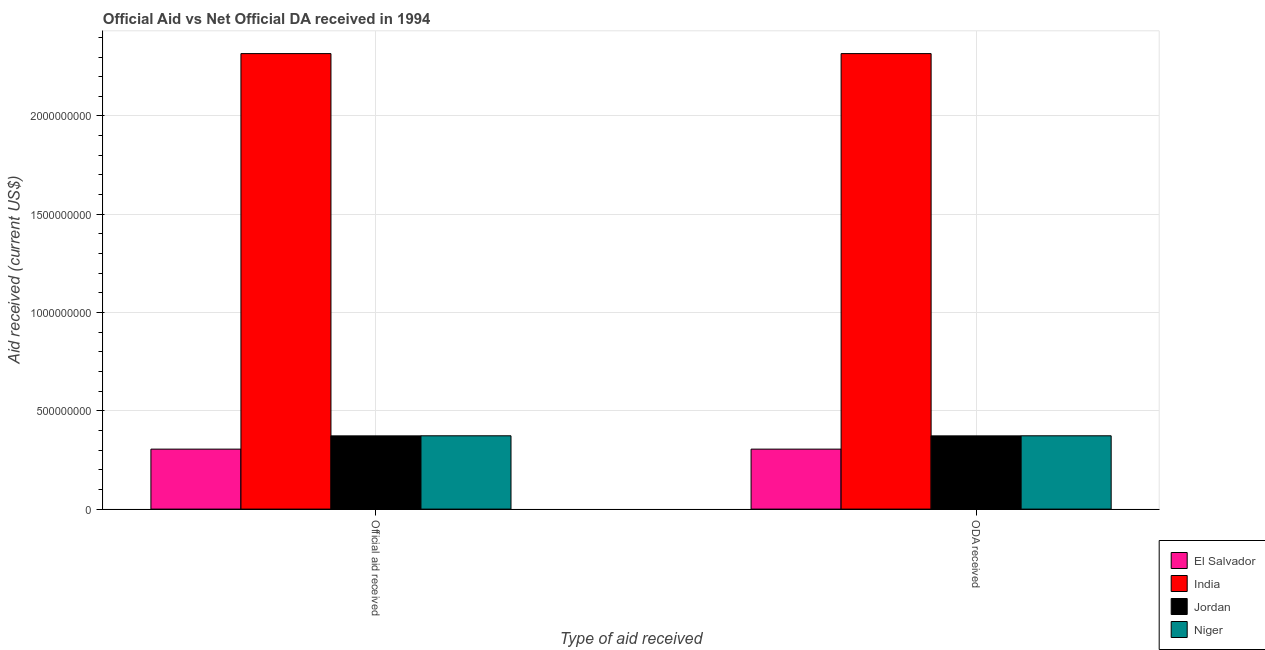How many groups of bars are there?
Your answer should be very brief. 2. Are the number of bars on each tick of the X-axis equal?
Your answer should be very brief. Yes. How many bars are there on the 1st tick from the left?
Give a very brief answer. 4. How many bars are there on the 2nd tick from the right?
Offer a terse response. 4. What is the label of the 2nd group of bars from the left?
Provide a succinct answer. ODA received. What is the oda received in India?
Keep it short and to the point. 2.32e+09. Across all countries, what is the maximum official aid received?
Keep it short and to the point. 2.32e+09. Across all countries, what is the minimum oda received?
Your answer should be compact. 3.05e+08. In which country was the oda received maximum?
Make the answer very short. India. In which country was the official aid received minimum?
Give a very brief answer. El Salvador. What is the total oda received in the graph?
Your answer should be very brief. 3.37e+09. What is the difference between the official aid received in India and that in El Salvador?
Offer a terse response. 2.01e+09. What is the difference between the official aid received in India and the oda received in Jordan?
Your response must be concise. 1.94e+09. What is the average oda received per country?
Your answer should be very brief. 8.42e+08. In how many countries, is the official aid received greater than 100000000 US$?
Your answer should be compact. 4. What is the ratio of the official aid received in India to that in Jordan?
Your answer should be very brief. 6.22. What does the 3rd bar from the left in Official aid received represents?
Your answer should be very brief. Jordan. What does the 1st bar from the right in Official aid received represents?
Make the answer very short. Niger. How many bars are there?
Provide a short and direct response. 8. Are the values on the major ticks of Y-axis written in scientific E-notation?
Your response must be concise. No. Does the graph contain any zero values?
Keep it short and to the point. No. How many legend labels are there?
Keep it short and to the point. 4. How are the legend labels stacked?
Provide a succinct answer. Vertical. What is the title of the graph?
Your response must be concise. Official Aid vs Net Official DA received in 1994 . Does "Barbados" appear as one of the legend labels in the graph?
Make the answer very short. No. What is the label or title of the X-axis?
Ensure brevity in your answer.  Type of aid received. What is the label or title of the Y-axis?
Offer a very short reply. Aid received (current US$). What is the Aid received (current US$) of El Salvador in Official aid received?
Your response must be concise. 3.05e+08. What is the Aid received (current US$) of India in Official aid received?
Offer a terse response. 2.32e+09. What is the Aid received (current US$) of Jordan in Official aid received?
Keep it short and to the point. 3.73e+08. What is the Aid received (current US$) in Niger in Official aid received?
Give a very brief answer. 3.73e+08. What is the Aid received (current US$) in El Salvador in ODA received?
Give a very brief answer. 3.05e+08. What is the Aid received (current US$) in India in ODA received?
Offer a very short reply. 2.32e+09. What is the Aid received (current US$) of Jordan in ODA received?
Keep it short and to the point. 3.73e+08. What is the Aid received (current US$) in Niger in ODA received?
Provide a short and direct response. 3.73e+08. Across all Type of aid received, what is the maximum Aid received (current US$) in El Salvador?
Make the answer very short. 3.05e+08. Across all Type of aid received, what is the maximum Aid received (current US$) in India?
Offer a terse response. 2.32e+09. Across all Type of aid received, what is the maximum Aid received (current US$) in Jordan?
Ensure brevity in your answer.  3.73e+08. Across all Type of aid received, what is the maximum Aid received (current US$) in Niger?
Offer a very short reply. 3.73e+08. Across all Type of aid received, what is the minimum Aid received (current US$) of El Salvador?
Offer a terse response. 3.05e+08. Across all Type of aid received, what is the minimum Aid received (current US$) in India?
Your answer should be compact. 2.32e+09. Across all Type of aid received, what is the minimum Aid received (current US$) in Jordan?
Offer a very short reply. 3.73e+08. Across all Type of aid received, what is the minimum Aid received (current US$) in Niger?
Give a very brief answer. 3.73e+08. What is the total Aid received (current US$) of El Salvador in the graph?
Provide a short and direct response. 6.10e+08. What is the total Aid received (current US$) in India in the graph?
Ensure brevity in your answer.  4.63e+09. What is the total Aid received (current US$) of Jordan in the graph?
Keep it short and to the point. 7.45e+08. What is the total Aid received (current US$) in Niger in the graph?
Offer a very short reply. 7.46e+08. What is the difference between the Aid received (current US$) in Niger in Official aid received and that in ODA received?
Offer a terse response. 0. What is the difference between the Aid received (current US$) in El Salvador in Official aid received and the Aid received (current US$) in India in ODA received?
Provide a short and direct response. -2.01e+09. What is the difference between the Aid received (current US$) in El Salvador in Official aid received and the Aid received (current US$) in Jordan in ODA received?
Make the answer very short. -6.74e+07. What is the difference between the Aid received (current US$) of El Salvador in Official aid received and the Aid received (current US$) of Niger in ODA received?
Offer a very short reply. -6.78e+07. What is the difference between the Aid received (current US$) of India in Official aid received and the Aid received (current US$) of Jordan in ODA received?
Offer a terse response. 1.94e+09. What is the difference between the Aid received (current US$) in India in Official aid received and the Aid received (current US$) in Niger in ODA received?
Your answer should be compact. 1.94e+09. What is the difference between the Aid received (current US$) in Jordan in Official aid received and the Aid received (current US$) in Niger in ODA received?
Provide a succinct answer. -4.00e+05. What is the average Aid received (current US$) in El Salvador per Type of aid received?
Ensure brevity in your answer.  3.05e+08. What is the average Aid received (current US$) in India per Type of aid received?
Provide a succinct answer. 2.32e+09. What is the average Aid received (current US$) of Jordan per Type of aid received?
Your response must be concise. 3.73e+08. What is the average Aid received (current US$) of Niger per Type of aid received?
Provide a short and direct response. 3.73e+08. What is the difference between the Aid received (current US$) in El Salvador and Aid received (current US$) in India in Official aid received?
Your answer should be compact. -2.01e+09. What is the difference between the Aid received (current US$) in El Salvador and Aid received (current US$) in Jordan in Official aid received?
Offer a very short reply. -6.74e+07. What is the difference between the Aid received (current US$) of El Salvador and Aid received (current US$) of Niger in Official aid received?
Your response must be concise. -6.78e+07. What is the difference between the Aid received (current US$) in India and Aid received (current US$) in Jordan in Official aid received?
Give a very brief answer. 1.94e+09. What is the difference between the Aid received (current US$) in India and Aid received (current US$) in Niger in Official aid received?
Offer a terse response. 1.94e+09. What is the difference between the Aid received (current US$) of Jordan and Aid received (current US$) of Niger in Official aid received?
Make the answer very short. -4.00e+05. What is the difference between the Aid received (current US$) of El Salvador and Aid received (current US$) of India in ODA received?
Give a very brief answer. -2.01e+09. What is the difference between the Aid received (current US$) of El Salvador and Aid received (current US$) of Jordan in ODA received?
Give a very brief answer. -6.74e+07. What is the difference between the Aid received (current US$) of El Salvador and Aid received (current US$) of Niger in ODA received?
Your answer should be very brief. -6.78e+07. What is the difference between the Aid received (current US$) of India and Aid received (current US$) of Jordan in ODA received?
Your response must be concise. 1.94e+09. What is the difference between the Aid received (current US$) in India and Aid received (current US$) in Niger in ODA received?
Give a very brief answer. 1.94e+09. What is the difference between the Aid received (current US$) of Jordan and Aid received (current US$) of Niger in ODA received?
Provide a succinct answer. -4.00e+05. What is the ratio of the Aid received (current US$) of El Salvador in Official aid received to that in ODA received?
Offer a very short reply. 1. What is the ratio of the Aid received (current US$) of India in Official aid received to that in ODA received?
Provide a succinct answer. 1. What is the difference between the highest and the second highest Aid received (current US$) of India?
Provide a short and direct response. 0. What is the difference between the highest and the second highest Aid received (current US$) of Jordan?
Offer a very short reply. 0. What is the difference between the highest and the second highest Aid received (current US$) in Niger?
Offer a terse response. 0. What is the difference between the highest and the lowest Aid received (current US$) in El Salvador?
Offer a terse response. 0. 